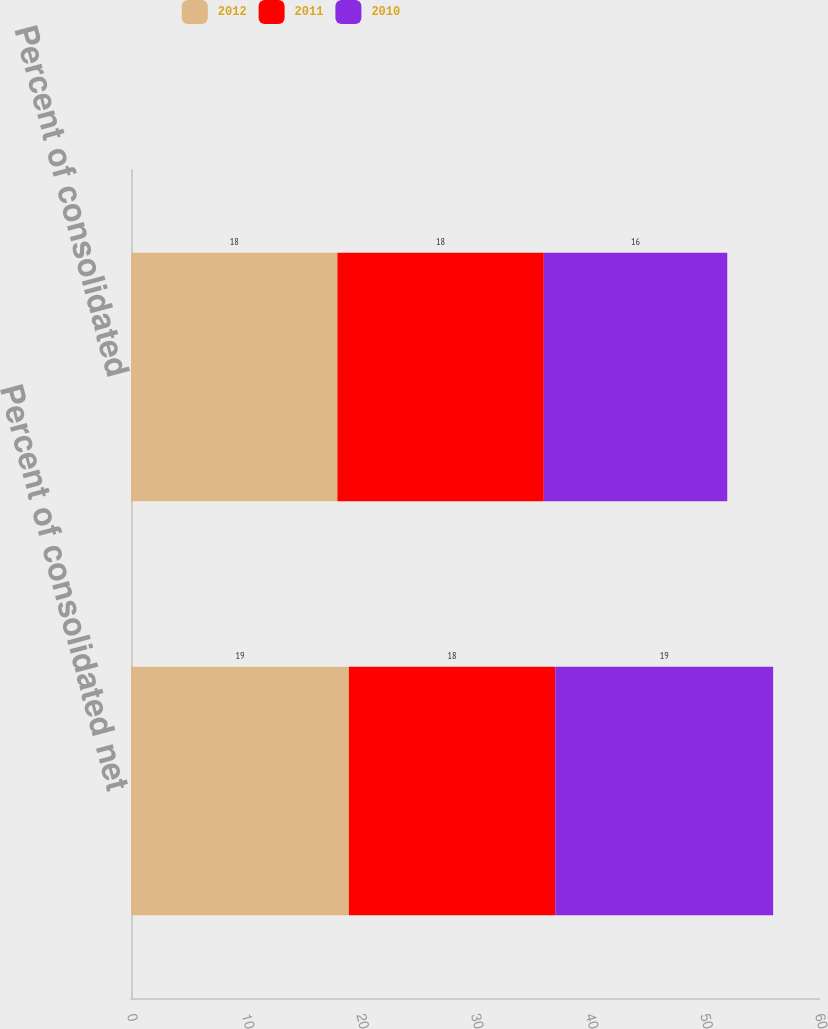Convert chart. <chart><loc_0><loc_0><loc_500><loc_500><stacked_bar_chart><ecel><fcel>Percent of consolidated net<fcel>Percent of consolidated<nl><fcel>2012<fcel>19<fcel>18<nl><fcel>2011<fcel>18<fcel>18<nl><fcel>2010<fcel>19<fcel>16<nl></chart> 